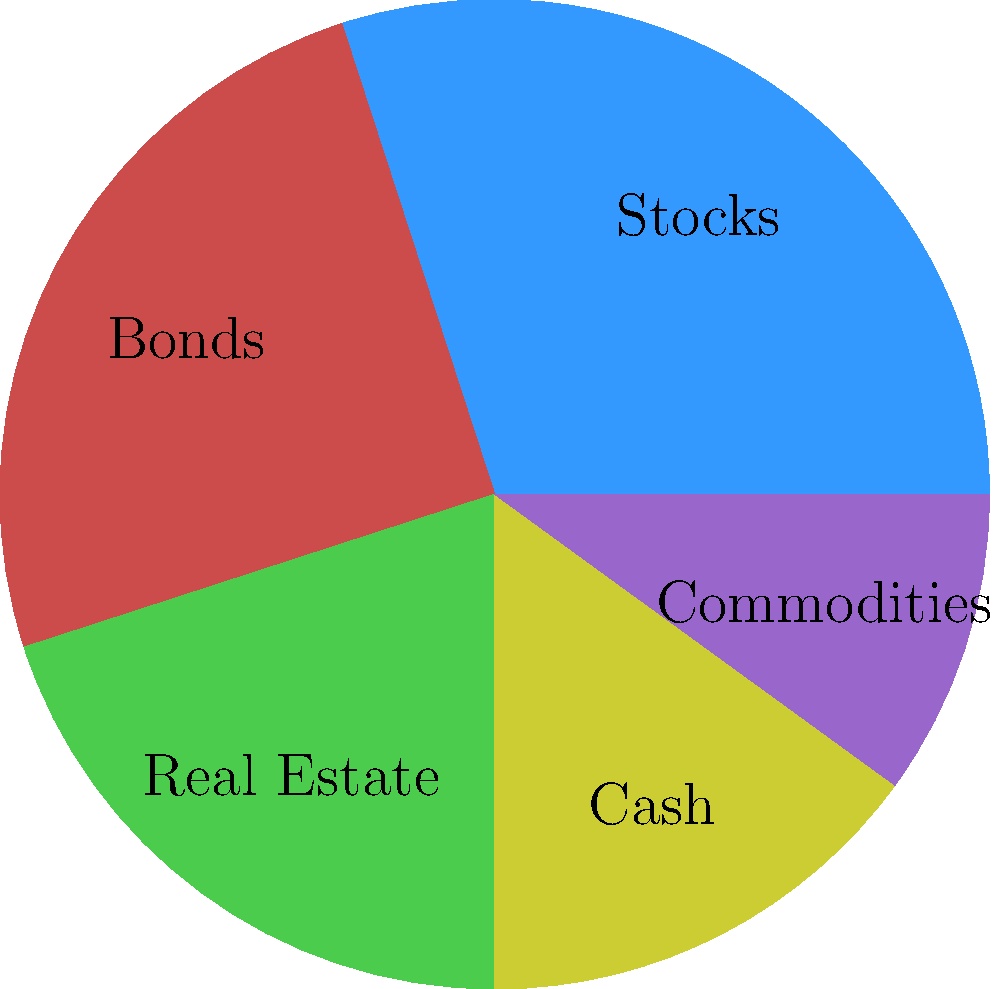Based on the pie chart showing asset allocation in a diversified portfolio, calculate the Herfindahl-Hirschman Index (HHI) to measure portfolio concentration. The HHI is calculated as the sum of squared percentage weights of each asset class. What does the resulting HHI indicate about the portfolio's diversification? To calculate the Herfindahl-Hirschman Index (HHI), we'll follow these steps:

1. Identify the percentage weights of each asset class:
   Stocks: 30%
   Bonds: 25%
   Real Estate: 20%
   Cash: 15%
   Commodities: 10%

2. Square each percentage weight:
   Stocks: $30^2 = 900$
   Bonds: $25^2 = 625$
   Real Estate: $20^2 = 400$
   Cash: $15^2 = 225$
   Commodities: $10^2 = 100$

3. Sum the squared percentages:
   HHI = 900 + 625 + 400 + 225 + 100 = 2250

4. Interpret the result:
   The HHI ranges from 0 to 10,000, where:
   - Values below 1,500 indicate unconcentrated (well-diversified) portfolios
   - Values between 1,500 and 2,500 indicate moderate concentration
   - Values above 2,500 indicate high concentration

With an HHI of 2,250, this portfolio shows moderate concentration. While there is some diversification across asset classes, there's still a relatively high allocation to stocks and bonds, which increases the concentration.
Answer: HHI = 2,250; indicates moderate concentration with some diversification. 